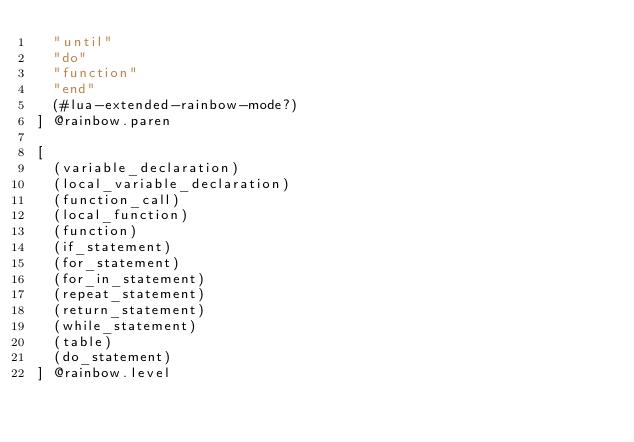<code> <loc_0><loc_0><loc_500><loc_500><_Scheme_>  "until"
  "do"
  "function"
  "end"
  (#lua-extended-rainbow-mode?)
] @rainbow.paren

[
  (variable_declaration)
  (local_variable_declaration)
  (function_call)
  (local_function)
  (function)
  (if_statement)
  (for_statement)
  (for_in_statement)
  (repeat_statement)
  (return_statement)
  (while_statement)
  (table)
  (do_statement)
] @rainbow.level
</code> 